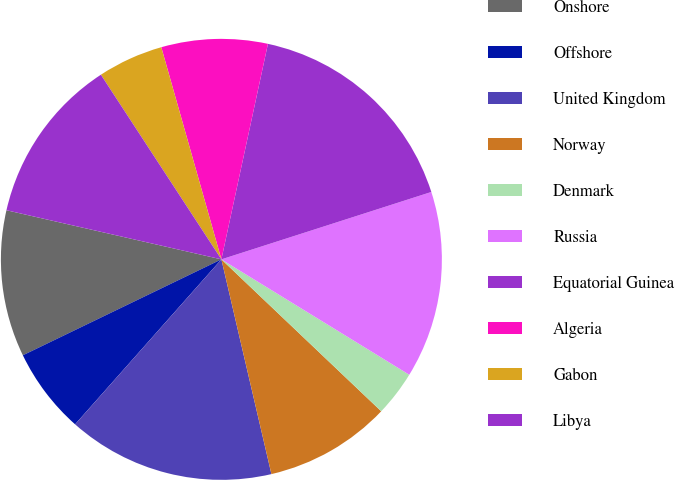<chart> <loc_0><loc_0><loc_500><loc_500><pie_chart><fcel>Onshore<fcel>Offshore<fcel>United Kingdom<fcel>Norway<fcel>Denmark<fcel>Russia<fcel>Equatorial Guinea<fcel>Algeria<fcel>Gabon<fcel>Libya<nl><fcel>10.74%<fcel>6.29%<fcel>15.19%<fcel>9.26%<fcel>3.33%<fcel>13.71%<fcel>16.67%<fcel>7.78%<fcel>4.81%<fcel>12.22%<nl></chart> 